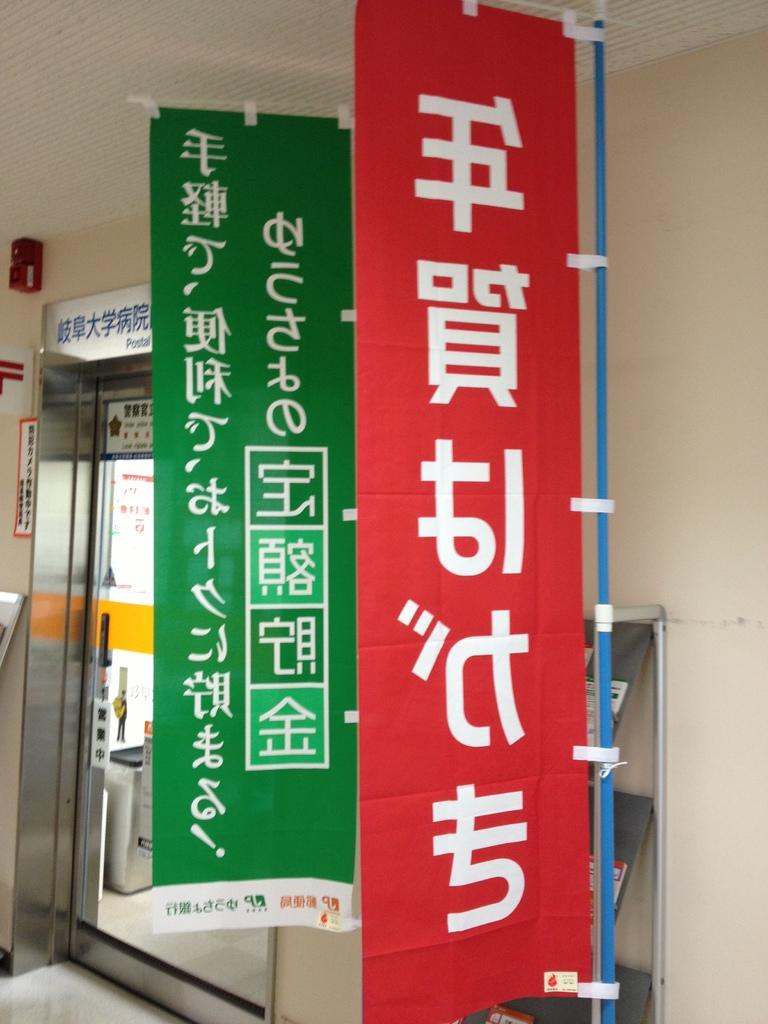What colors are the clothes on the right side of the image? There are two clothes on the right side of the image, one in red color and the other in green color. What is the material of the wall on the left side of the image? The wall on the left side of the image is a glass wall. How does the sense of smell guide the clothes in the image? The sense of smell does not guide the clothes in the image, as there is no indication of any olfactory influence on the clothes. 